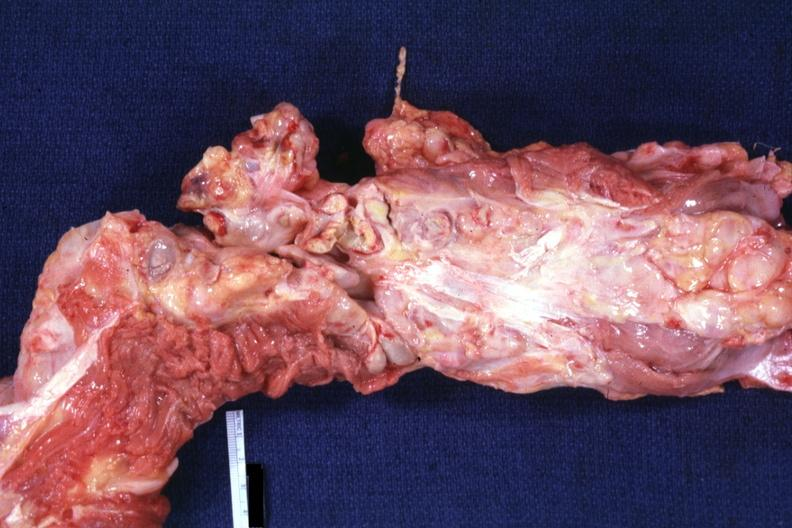what is present?
Answer the question using a single word or phrase. Lymph node 